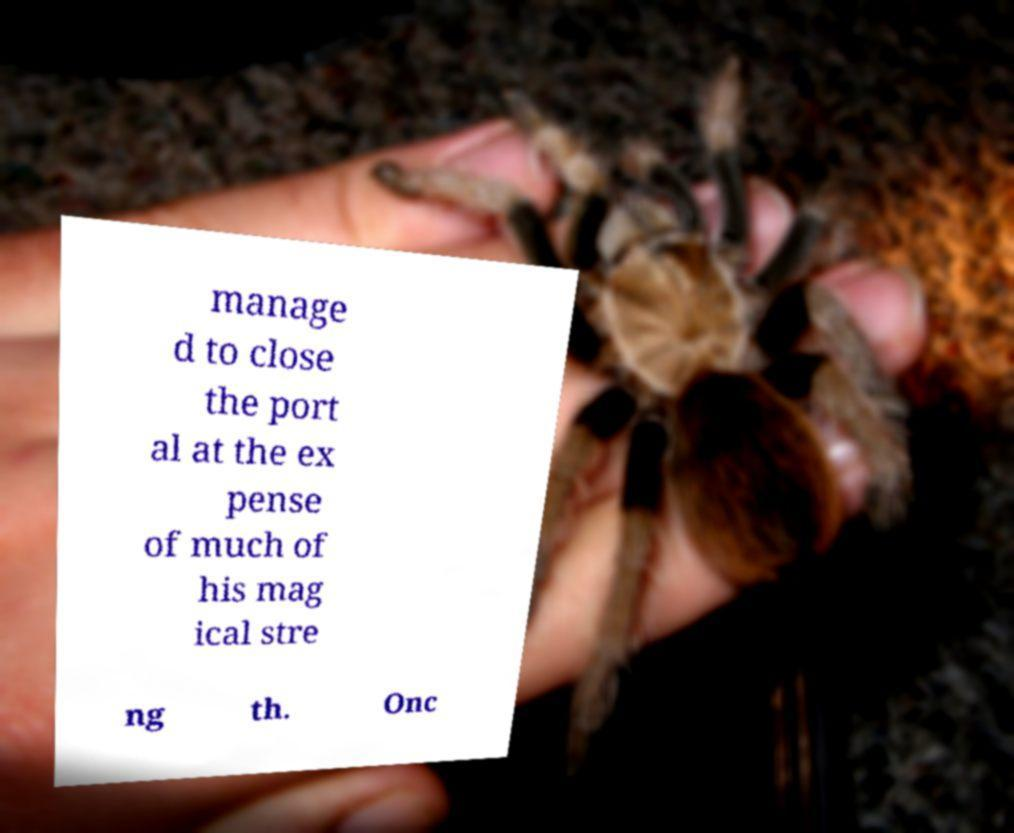There's text embedded in this image that I need extracted. Can you transcribe it verbatim? manage d to close the port al at the ex pense of much of his mag ical stre ng th. Onc 